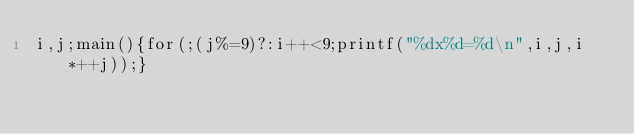Convert code to text. <code><loc_0><loc_0><loc_500><loc_500><_C_>i,j;main(){for(;(j%=9)?:i++<9;printf("%dx%d=%d\n",i,j,i*++j));}</code> 